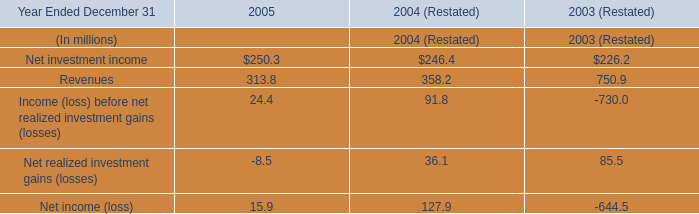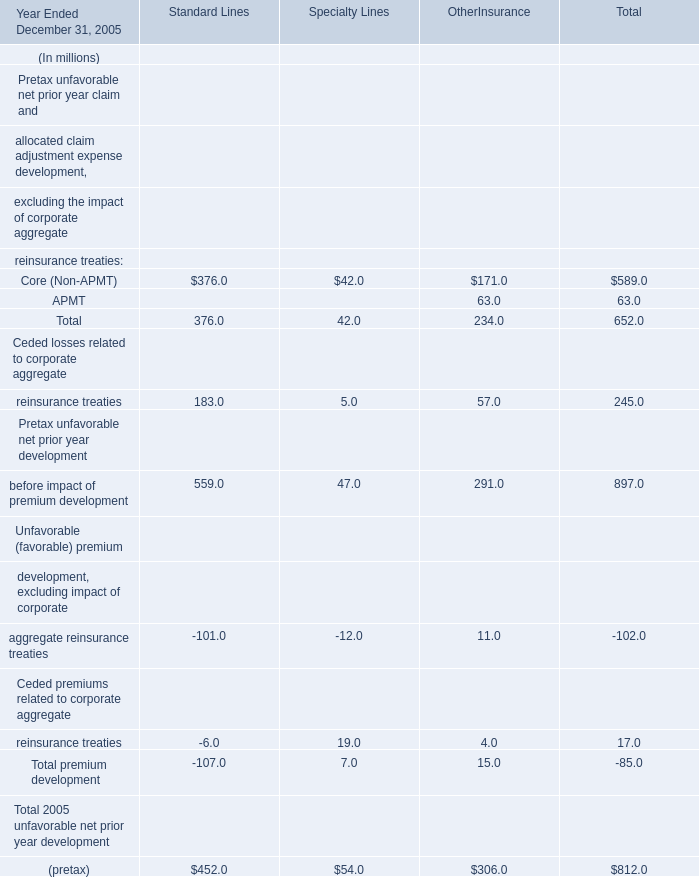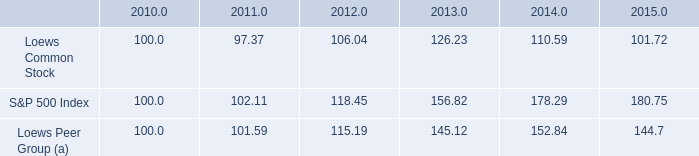what is the roi of an investment in loews common stock from 2010 to 2012? 
Computations: ((106.04 - 100) / 100)
Answer: 0.0604. 